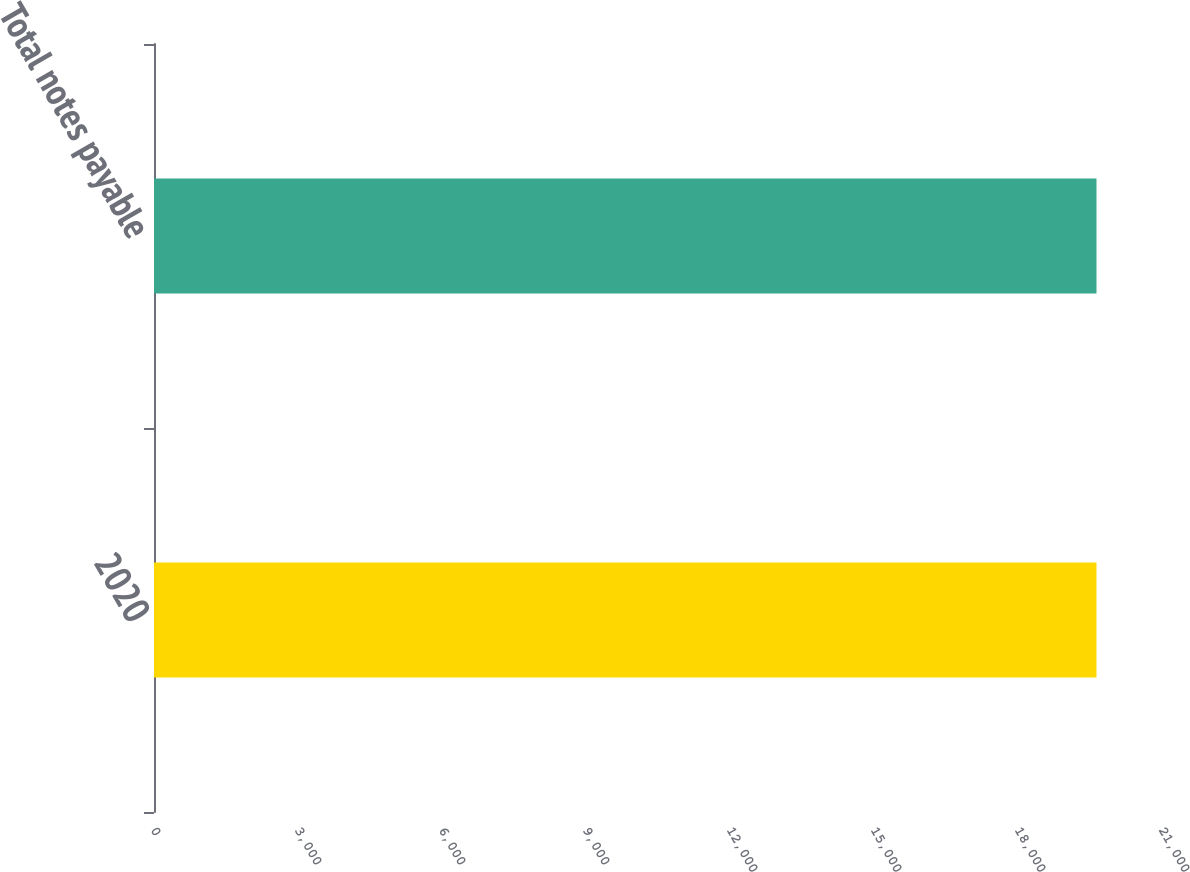Convert chart to OTSL. <chart><loc_0><loc_0><loc_500><loc_500><bar_chart><fcel>2020<fcel>Total notes payable<nl><fcel>19635<fcel>19635.1<nl></chart> 